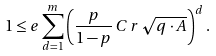<formula> <loc_0><loc_0><loc_500><loc_500>1 \leq e \sum _ { d = 1 } ^ { m } \left ( \frac { p } { 1 - p } \, C \, r \, \sqrt { q \cdot A } \right ) ^ { d } .</formula> 